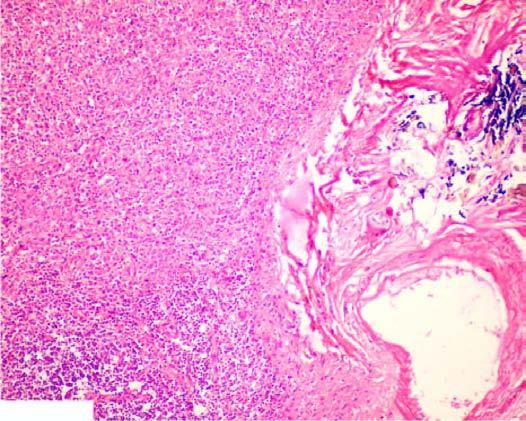s gamna-gandy body also seen?
Answer the question using a single word or phrase. Yes 